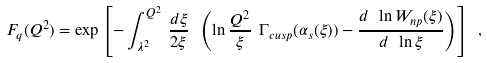<formula> <loc_0><loc_0><loc_500><loc_500>F _ { q } ( Q ^ { 2 } ) = \exp \left [ - \int _ { \lambda ^ { 2 } } ^ { Q ^ { 2 } } \, { \frac { d \xi } { 2 \xi } } \ \left ( \ln { \frac { Q ^ { 2 } } { \xi } } \ \Gamma _ { c u s p } ( \alpha _ { s } ( \xi ) ) - { \frac { d \ \ln W _ { n p } ( \xi ) } { d \ \ln \xi } } \right ) \right ] \ ,</formula> 